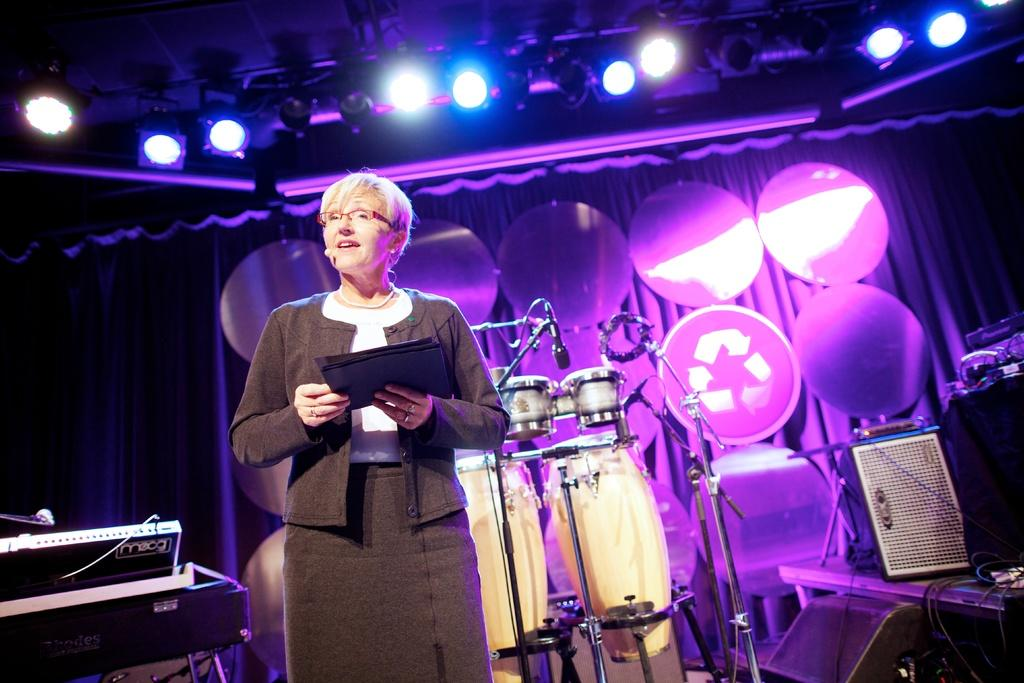Who is the main subject in the image? There is a woman in the image. What is the woman doing in the image? The woman is standing and speaking in front of a microphone. What is the woman holding in her hand? The woman is holding papers in her hand. What else can be seen in the image besides the woman? There are musical instruments visible in the image. How many cents are visible on the floor in the image? There are no cents visible on the floor in the image. What type of sweater is the woman wearing in the image? The image does not show the woman wearing a sweater, so it cannot be determined from the image. 